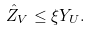Convert formula to latex. <formula><loc_0><loc_0><loc_500><loc_500>\hat { Z } _ { V } \leq \xi Y _ { U } .</formula> 